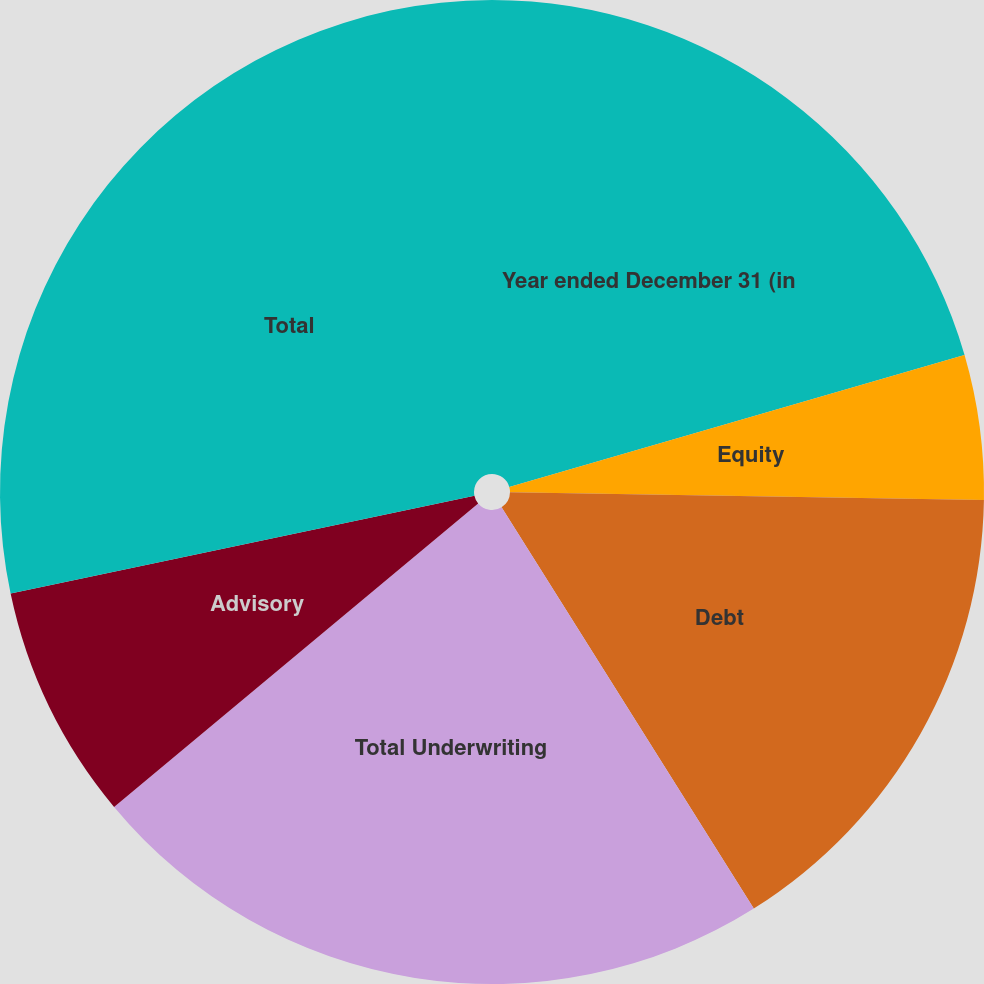Convert chart to OTSL. <chart><loc_0><loc_0><loc_500><loc_500><pie_chart><fcel>Year ended December 31 (in<fcel>Equity<fcel>Debt<fcel>Total Underwriting<fcel>Advisory<fcel>Total<nl><fcel>20.51%<fcel>4.75%<fcel>15.81%<fcel>22.87%<fcel>7.75%<fcel>28.31%<nl></chart> 